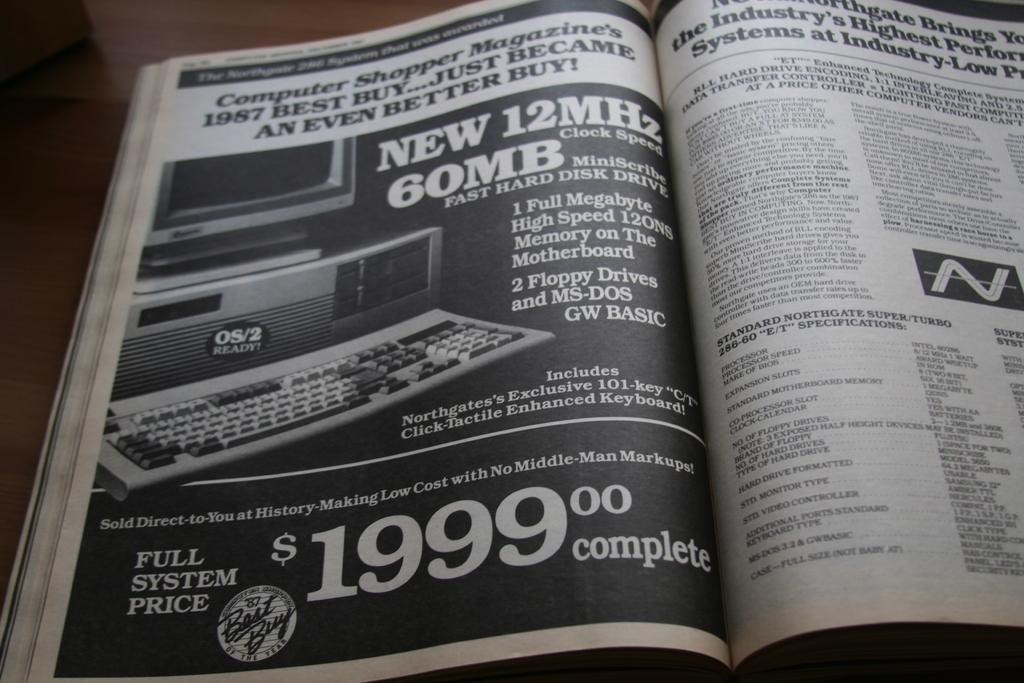Provide a one-sentence caption for the provided image. The price for the full system advertised is $1999.00. 